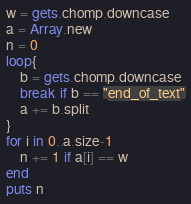<code> <loc_0><loc_0><loc_500><loc_500><_Ruby_>w = gets.chomp.downcase
a = Array.new
n = 0
loop{
	b = gets.chomp.downcase
	break if b == "end_of_text"
	a += b.split
}
for i in 0..a.size-1
	n += 1 if a[i] == w
end
puts n</code> 